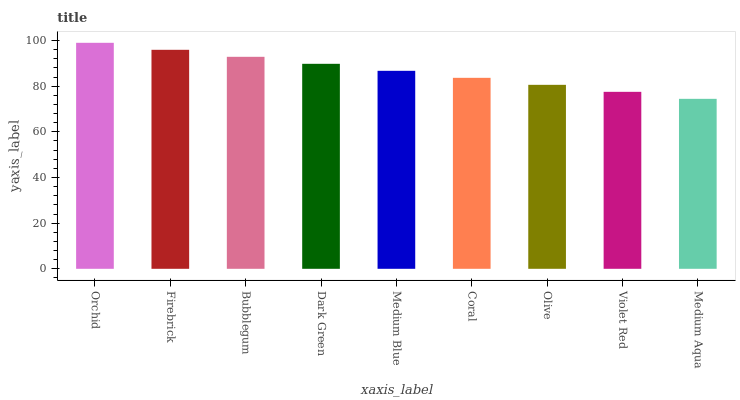Is Medium Aqua the minimum?
Answer yes or no. Yes. Is Orchid the maximum?
Answer yes or no. Yes. Is Firebrick the minimum?
Answer yes or no. No. Is Firebrick the maximum?
Answer yes or no. No. Is Orchid greater than Firebrick?
Answer yes or no. Yes. Is Firebrick less than Orchid?
Answer yes or no. Yes. Is Firebrick greater than Orchid?
Answer yes or no. No. Is Orchid less than Firebrick?
Answer yes or no. No. Is Medium Blue the high median?
Answer yes or no. Yes. Is Medium Blue the low median?
Answer yes or no. Yes. Is Medium Aqua the high median?
Answer yes or no. No. Is Orchid the low median?
Answer yes or no. No. 